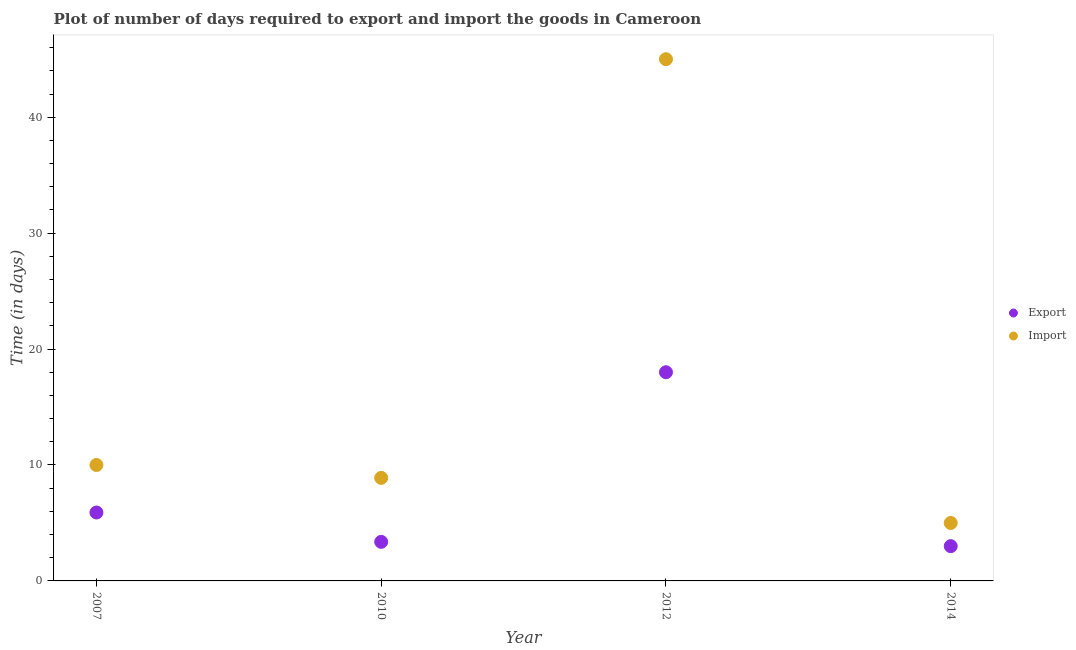In which year was the time required to export minimum?
Offer a terse response. 2014. What is the total time required to export in the graph?
Your response must be concise. 30.27. What is the difference between the time required to import in 2010 and the time required to export in 2012?
Keep it short and to the point. -9.11. What is the average time required to import per year?
Provide a short and direct response. 17.22. In the year 2014, what is the difference between the time required to import and time required to export?
Offer a terse response. 2. In how many years, is the time required to export greater than 34 days?
Your response must be concise. 0. What is the difference between the highest and the second highest time required to import?
Keep it short and to the point. 35. Does the time required to import monotonically increase over the years?
Your response must be concise. No. Is the time required to import strictly greater than the time required to export over the years?
Give a very brief answer. Yes. Are the values on the major ticks of Y-axis written in scientific E-notation?
Ensure brevity in your answer.  No. Does the graph contain any zero values?
Make the answer very short. No. Does the graph contain grids?
Your response must be concise. No. How many legend labels are there?
Provide a succinct answer. 2. How are the legend labels stacked?
Give a very brief answer. Vertical. What is the title of the graph?
Your answer should be compact. Plot of number of days required to export and import the goods in Cameroon. What is the label or title of the X-axis?
Provide a succinct answer. Year. What is the label or title of the Y-axis?
Offer a very short reply. Time (in days). What is the Time (in days) of Export in 2007?
Ensure brevity in your answer.  5.9. What is the Time (in days) of Import in 2007?
Your answer should be very brief. 10. What is the Time (in days) in Export in 2010?
Provide a short and direct response. 3.37. What is the Time (in days) of Import in 2010?
Give a very brief answer. 8.89. What is the Time (in days) in Export in 2012?
Offer a terse response. 18. What is the Time (in days) of Export in 2014?
Your answer should be very brief. 3. Across all years, what is the maximum Time (in days) of Import?
Offer a terse response. 45. What is the total Time (in days) in Export in the graph?
Give a very brief answer. 30.27. What is the total Time (in days) of Import in the graph?
Your response must be concise. 68.89. What is the difference between the Time (in days) in Export in 2007 and that in 2010?
Give a very brief answer. 2.53. What is the difference between the Time (in days) of Import in 2007 and that in 2010?
Offer a terse response. 1.11. What is the difference between the Time (in days) in Import in 2007 and that in 2012?
Offer a very short reply. -35. What is the difference between the Time (in days) of Export in 2007 and that in 2014?
Your response must be concise. 2.9. What is the difference between the Time (in days) of Import in 2007 and that in 2014?
Your answer should be compact. 5. What is the difference between the Time (in days) of Export in 2010 and that in 2012?
Offer a very short reply. -14.63. What is the difference between the Time (in days) in Import in 2010 and that in 2012?
Give a very brief answer. -36.11. What is the difference between the Time (in days) of Export in 2010 and that in 2014?
Provide a short and direct response. 0.37. What is the difference between the Time (in days) of Import in 2010 and that in 2014?
Your response must be concise. 3.89. What is the difference between the Time (in days) in Export in 2012 and that in 2014?
Ensure brevity in your answer.  15. What is the difference between the Time (in days) of Export in 2007 and the Time (in days) of Import in 2010?
Give a very brief answer. -2.99. What is the difference between the Time (in days) in Export in 2007 and the Time (in days) in Import in 2012?
Your answer should be very brief. -39.1. What is the difference between the Time (in days) in Export in 2007 and the Time (in days) in Import in 2014?
Your response must be concise. 0.9. What is the difference between the Time (in days) in Export in 2010 and the Time (in days) in Import in 2012?
Offer a terse response. -41.63. What is the difference between the Time (in days) of Export in 2010 and the Time (in days) of Import in 2014?
Your answer should be very brief. -1.63. What is the difference between the Time (in days) in Export in 2012 and the Time (in days) in Import in 2014?
Give a very brief answer. 13. What is the average Time (in days) of Export per year?
Make the answer very short. 7.57. What is the average Time (in days) in Import per year?
Keep it short and to the point. 17.22. In the year 2010, what is the difference between the Time (in days) of Export and Time (in days) of Import?
Provide a succinct answer. -5.52. In the year 2014, what is the difference between the Time (in days) of Export and Time (in days) of Import?
Your answer should be compact. -2. What is the ratio of the Time (in days) of Export in 2007 to that in 2010?
Your answer should be very brief. 1.75. What is the ratio of the Time (in days) of Import in 2007 to that in 2010?
Ensure brevity in your answer.  1.12. What is the ratio of the Time (in days) in Export in 2007 to that in 2012?
Provide a succinct answer. 0.33. What is the ratio of the Time (in days) of Import in 2007 to that in 2012?
Keep it short and to the point. 0.22. What is the ratio of the Time (in days) of Export in 2007 to that in 2014?
Offer a very short reply. 1.97. What is the ratio of the Time (in days) in Import in 2007 to that in 2014?
Ensure brevity in your answer.  2. What is the ratio of the Time (in days) of Export in 2010 to that in 2012?
Your response must be concise. 0.19. What is the ratio of the Time (in days) of Import in 2010 to that in 2012?
Make the answer very short. 0.2. What is the ratio of the Time (in days) of Export in 2010 to that in 2014?
Provide a short and direct response. 1.12. What is the ratio of the Time (in days) of Import in 2010 to that in 2014?
Provide a succinct answer. 1.78. What is the ratio of the Time (in days) in Export in 2012 to that in 2014?
Give a very brief answer. 6. What is the difference between the highest and the second highest Time (in days) in Import?
Offer a terse response. 35. What is the difference between the highest and the lowest Time (in days) of Export?
Offer a very short reply. 15. 